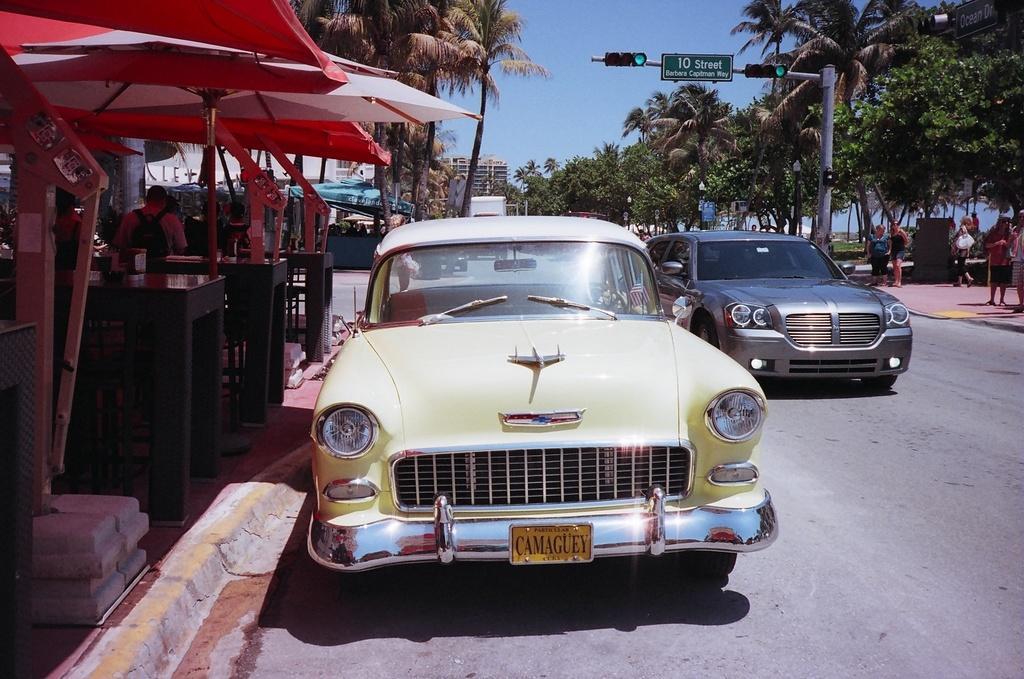In one or two sentences, can you explain what this image depicts? On the left side of the image there is a tent, beneath the tent there are a few people sitting in front of the table, beside them there are two cars on the road. On the other side of the image there are a few people standing on the pavement and there is a signal pole. In the background there are trees, buildings and the sky. 